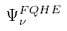Convert formula to latex. <formula><loc_0><loc_0><loc_500><loc_500>\Psi _ { \nu } ^ { F Q H E }</formula> 